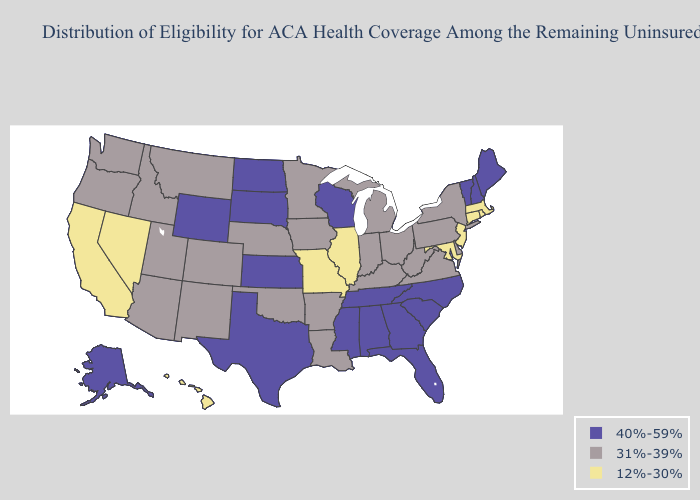Name the states that have a value in the range 40%-59%?
Answer briefly. Alabama, Alaska, Florida, Georgia, Kansas, Maine, Mississippi, New Hampshire, North Carolina, North Dakota, South Carolina, South Dakota, Tennessee, Texas, Vermont, Wisconsin, Wyoming. What is the lowest value in states that border Minnesota?
Short answer required. 31%-39%. Does Massachusetts have the highest value in the Northeast?
Keep it brief. No. What is the value of New Mexico?
Keep it brief. 31%-39%. What is the value of Pennsylvania?
Answer briefly. 31%-39%. What is the value of Alabama?
Short answer required. 40%-59%. Does the first symbol in the legend represent the smallest category?
Be succinct. No. What is the value of Wisconsin?
Concise answer only. 40%-59%. Does the map have missing data?
Concise answer only. No. What is the lowest value in states that border New Hampshire?
Keep it brief. 12%-30%. Does Arizona have the highest value in the USA?
Write a very short answer. No. What is the lowest value in the USA?
Give a very brief answer. 12%-30%. What is the value of Nevada?
Write a very short answer. 12%-30%. What is the value of Virginia?
Quick response, please. 31%-39%. Does North Dakota have a higher value than Louisiana?
Answer briefly. Yes. 